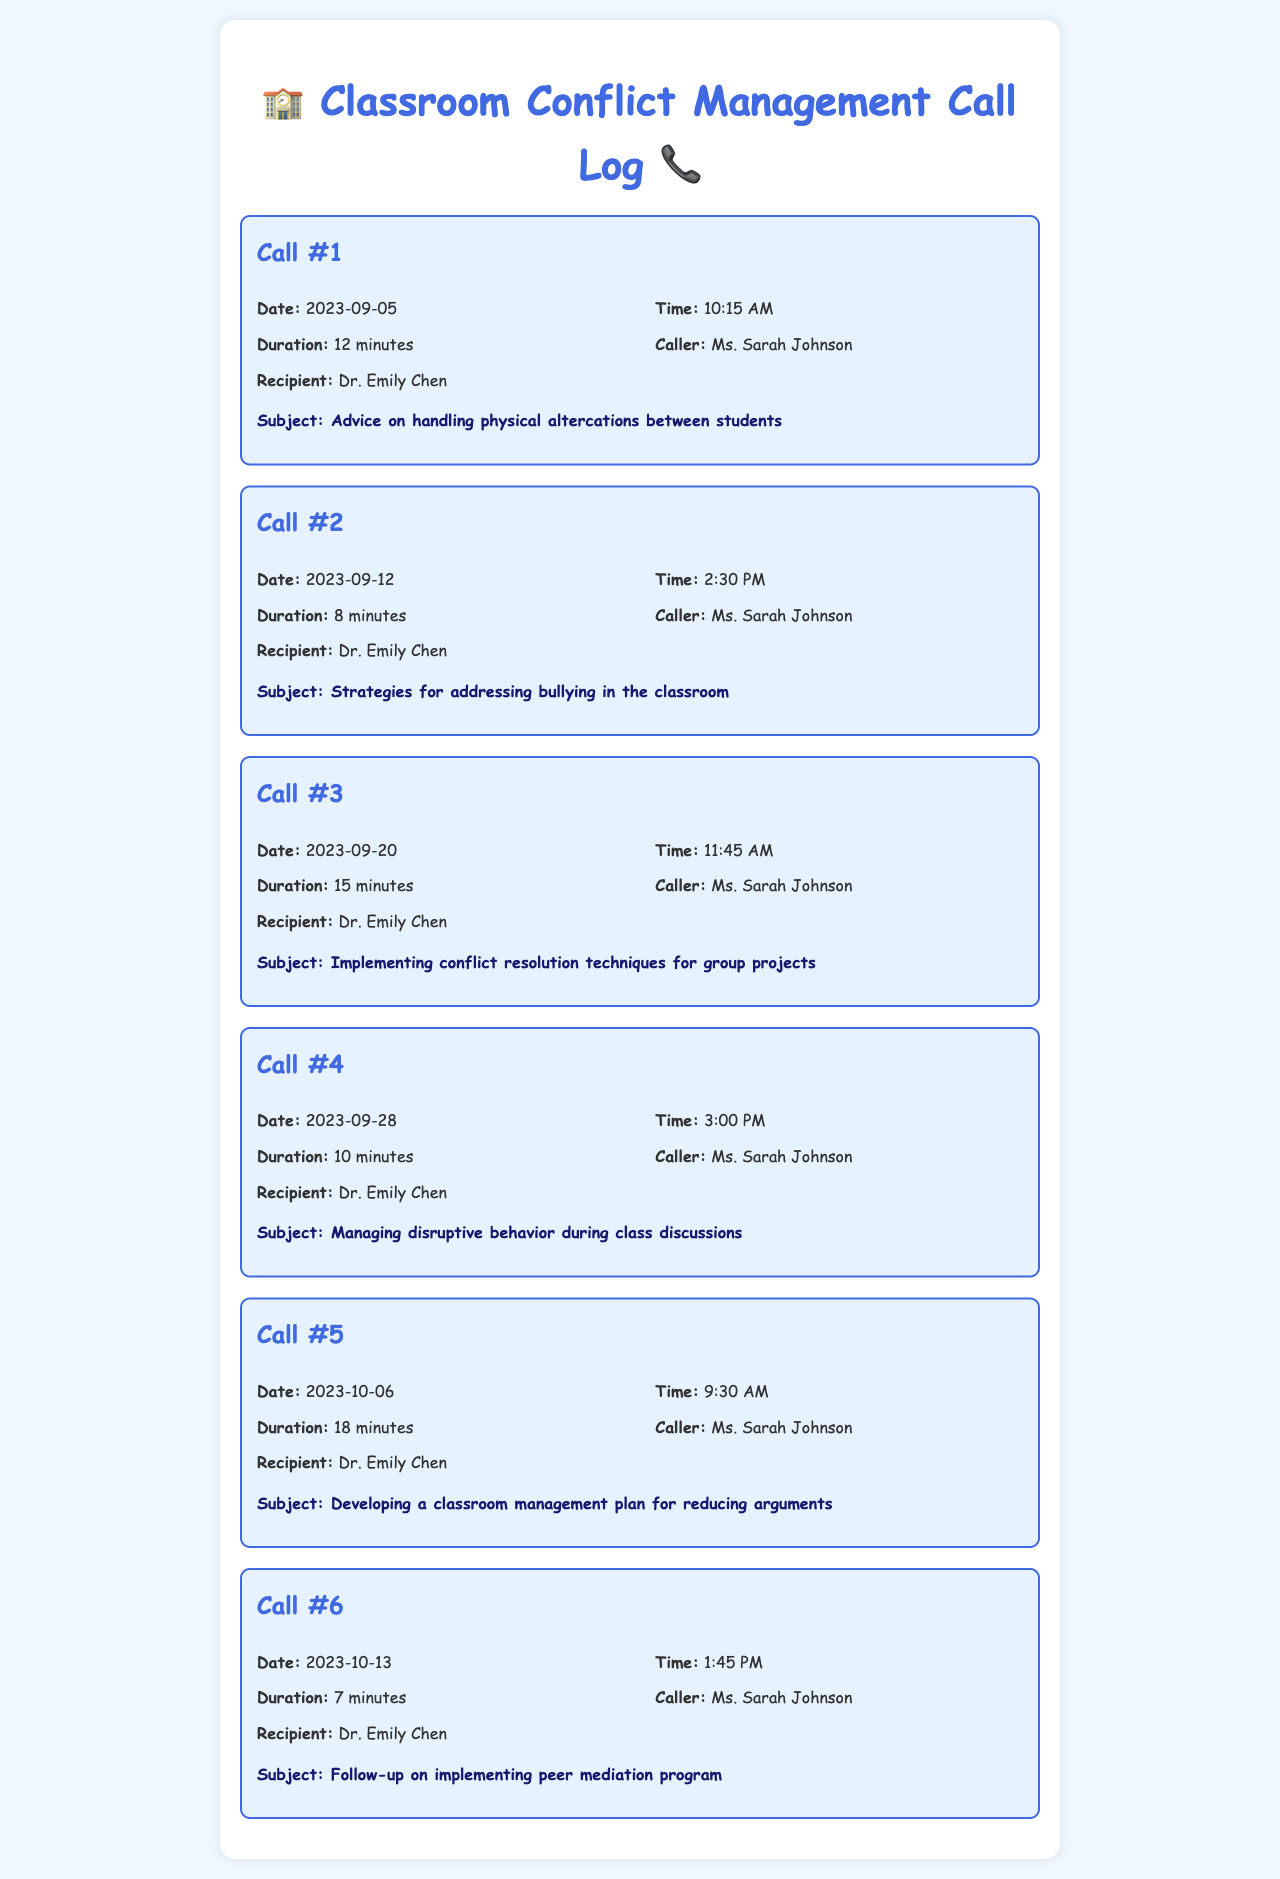What is the date of the first call? The first call was made on September 5, 2023, as indicated in the call log.
Answer: September 5, 2023 Who is the caller in all the calls? Each call's log identifies the caller as Ms. Sarah Johnson.
Answer: Ms. Sarah Johnson How long was the longest call? The longest call was on October 6, 2023, lasting 18 minutes, as stated in the duration details.
Answer: 18 minutes What subject was discussed in Call #3? Call #3's subject is specified in the log as implementing conflict resolution techniques for group projects.
Answer: Implementing conflict resolution techniques for group projects Which call focused on bullying issues? The call log states that Call #2 addresses strategies for addressing bullying in the classroom.
Answer: Call #2 What is the total number of calls logged? The document lists a total of six calls made by Ms. Sarah Johnson to Dr. Emily Chen.
Answer: 6 What was the recipient's name for all the calls? The call logs consistently state that Dr. Emily Chen is the recipient of all calls.
Answer: Dr. Emily Chen When was the last call made? The last call in the log was made on October 13, 2023, as per the entries provided.
Answer: October 13, 2023 